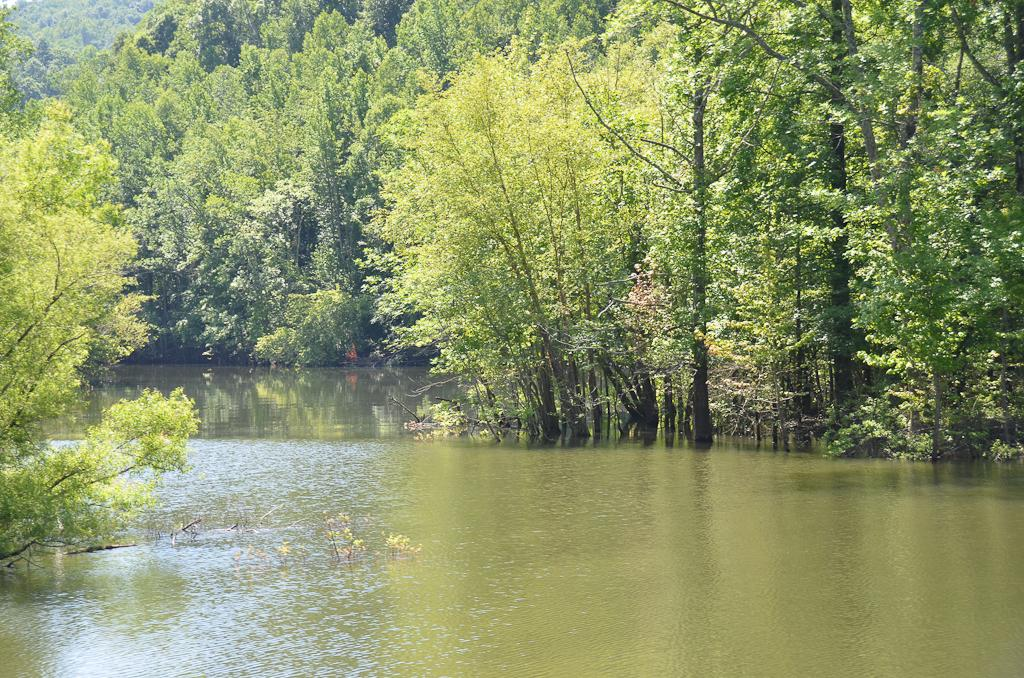What is the primary element visible in the image? There is water in the image. What can be seen in the distance in the image? There are trees in the background of the image. What type of van can be seen parked near the water in the image? There is no van present in the image; it only features water and trees in the background. 